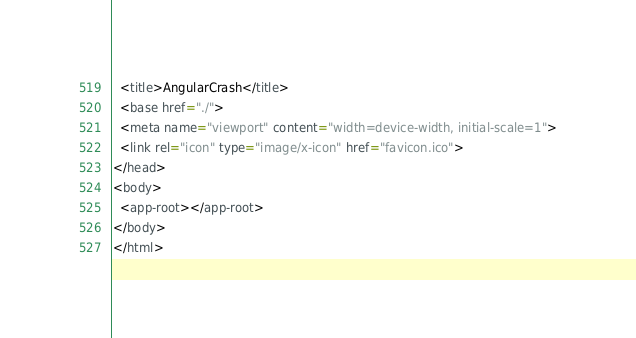Convert code to text. <code><loc_0><loc_0><loc_500><loc_500><_HTML_>  <title>AngularCrash</title>
  <base href="./">
  <meta name="viewport" content="width=device-width, initial-scale=1">
  <link rel="icon" type="image/x-icon" href="favicon.ico">
</head>
<body>
  <app-root></app-root>
</body>
</html>
</code> 